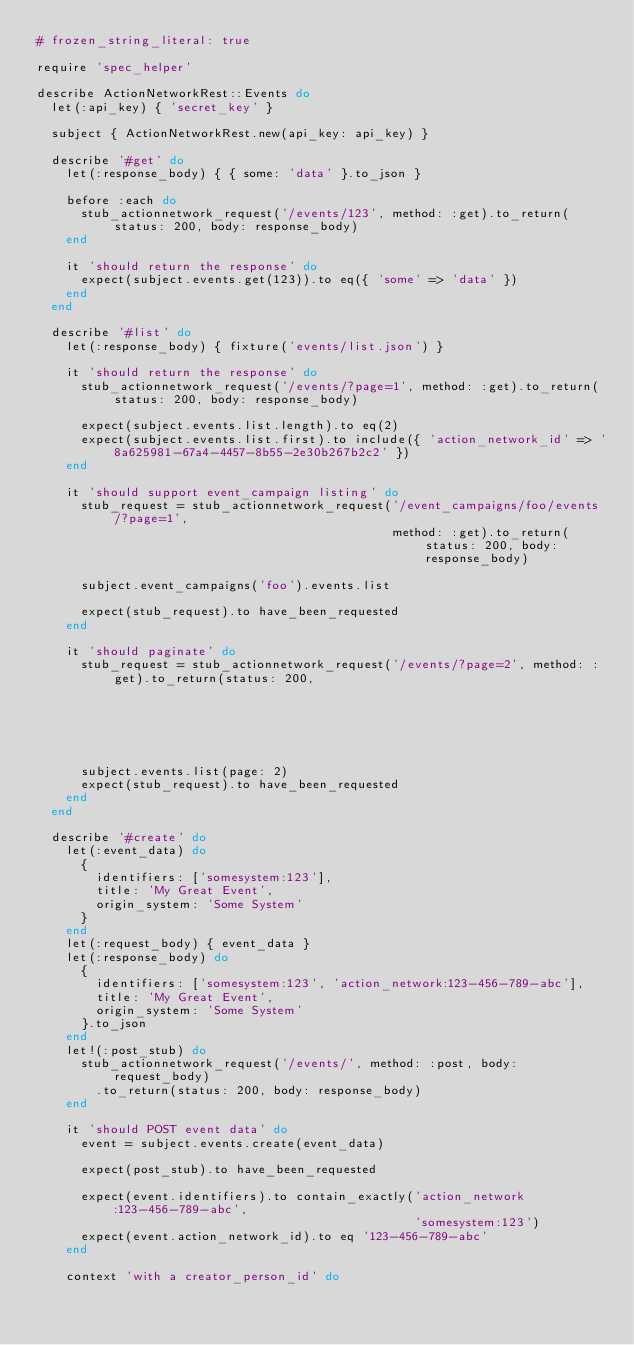Convert code to text. <code><loc_0><loc_0><loc_500><loc_500><_Ruby_># frozen_string_literal: true

require 'spec_helper'

describe ActionNetworkRest::Events do
  let(:api_key) { 'secret_key' }

  subject { ActionNetworkRest.new(api_key: api_key) }

  describe '#get' do
    let(:response_body) { { some: 'data' }.to_json }

    before :each do
      stub_actionnetwork_request('/events/123', method: :get).to_return(status: 200, body: response_body)
    end

    it 'should return the response' do
      expect(subject.events.get(123)).to eq({ 'some' => 'data' })
    end
  end

  describe '#list' do
    let(:response_body) { fixture('events/list.json') }

    it 'should return the response' do
      stub_actionnetwork_request('/events/?page=1', method: :get).to_return(status: 200, body: response_body)

      expect(subject.events.list.length).to eq(2)
      expect(subject.events.list.first).to include({ 'action_network_id' => '8a625981-67a4-4457-8b55-2e30b267b2c2' })
    end

    it 'should support event_campaign listing' do
      stub_request = stub_actionnetwork_request('/event_campaigns/foo/events/?page=1',
                                                method: :get).to_return(status: 200, body: response_body)

      subject.event_campaigns('foo').events.list

      expect(stub_request).to have_been_requested
    end

    it 'should paginate' do
      stub_request = stub_actionnetwork_request('/events/?page=2', method: :get).to_return(status: 200,
                                                                                           body: response_body)
      subject.events.list(page: 2)
      expect(stub_request).to have_been_requested
    end
  end

  describe '#create' do
    let(:event_data) do
      {
        identifiers: ['somesystem:123'],
        title: 'My Great Event',
        origin_system: 'Some System'
      }
    end
    let(:request_body) { event_data }
    let(:response_body) do
      {
        identifiers: ['somesystem:123', 'action_network:123-456-789-abc'],
        title: 'My Great Event',
        origin_system: 'Some System'
      }.to_json
    end
    let!(:post_stub) do
      stub_actionnetwork_request('/events/', method: :post, body: request_body)
        .to_return(status: 200, body: response_body)
    end

    it 'should POST event data' do
      event = subject.events.create(event_data)

      expect(post_stub).to have_been_requested

      expect(event.identifiers).to contain_exactly('action_network:123-456-789-abc',
                                                   'somesystem:123')
      expect(event.action_network_id).to eq '123-456-789-abc'
    end

    context 'with a creator_person_id' do</code> 